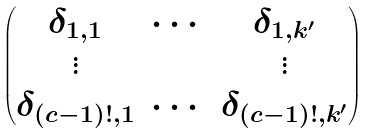<formula> <loc_0><loc_0><loc_500><loc_500>\begin{pmatrix} \delta _ { 1 , 1 } & \cdots & \delta _ { 1 , k ^ { \prime } } \\ \vdots & & \vdots \\ \delta _ { ( c - 1 ) ! , 1 } & \cdots & \delta _ { ( c - 1 ) ! , k ^ { \prime } } \end{pmatrix}</formula> 